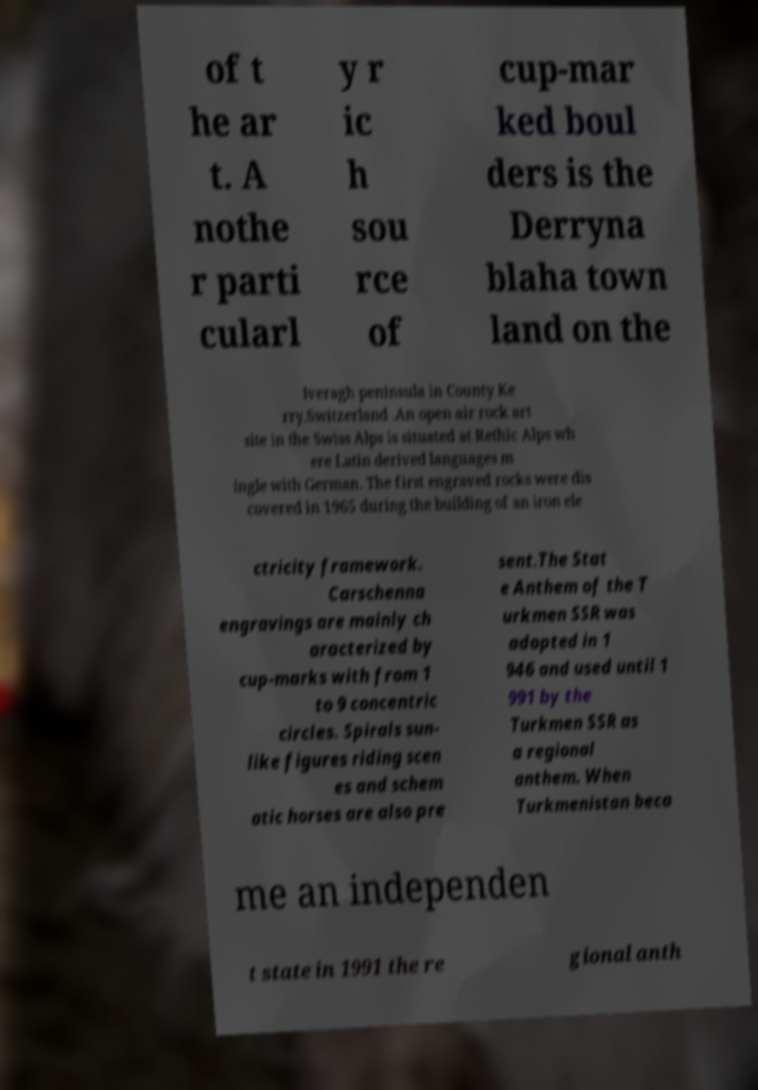What messages or text are displayed in this image? I need them in a readable, typed format. of t he ar t. A nothe r parti cularl y r ic h sou rce of cup-mar ked boul ders is the Derryna blaha town land on the Iveragh peninsula in County Ke rry.Switzerland .An open air rock art site in the Swiss Alps is situated at Rethic Alps wh ere Latin derived languages m ingle with German. The first engraved rocks were dis covered in 1965 during the building of an iron ele ctricity framework. Carschenna engravings are mainly ch aracterized by cup-marks with from 1 to 9 concentric circles. Spirals sun- like figures riding scen es and schem atic horses are also pre sent.The Stat e Anthem of the T urkmen SSR was adopted in 1 946 and used until 1 991 by the Turkmen SSR as a regional anthem. When Turkmenistan beca me an independen t state in 1991 the re gional anth 